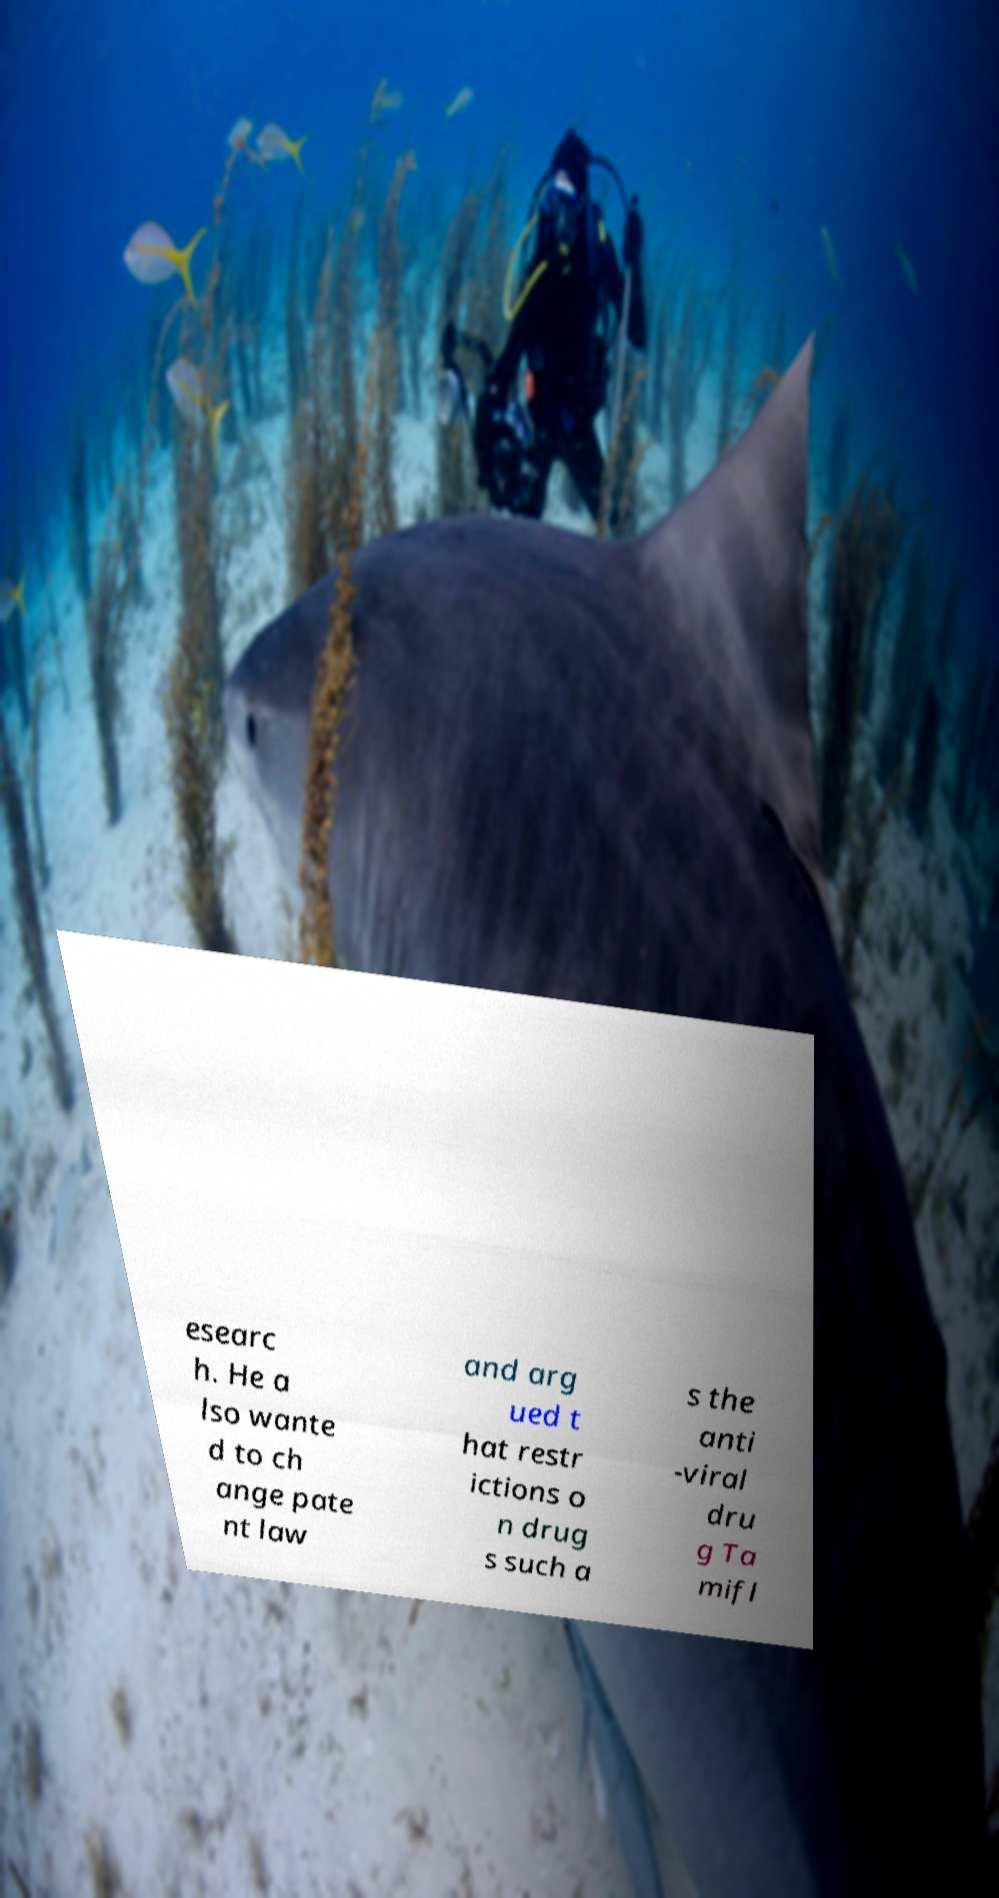Please identify and transcribe the text found in this image. esearc h. He a lso wante d to ch ange pate nt law and arg ued t hat restr ictions o n drug s such a s the anti -viral dru g Ta mifl 